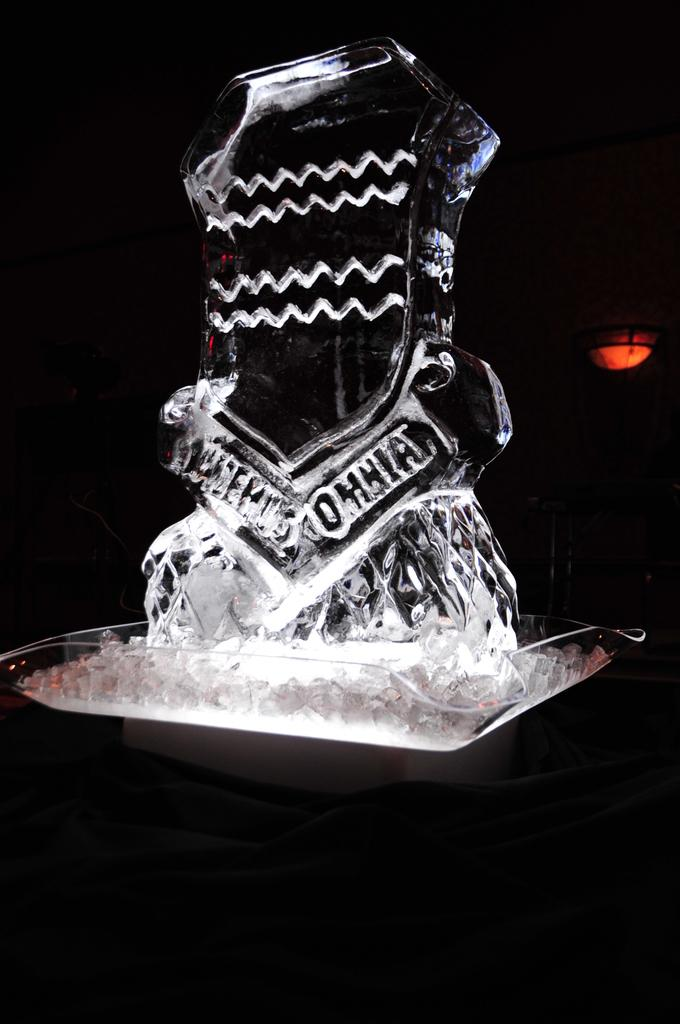What object is present in the image? There is a glass in the image. What color is the background of the image? The background of the image is black. What type of trade is being conducted in the image? There is no trade being conducted in the image; it only features a glass and a black background. How many times is the glass twisted in the image? The glass is not twisted in the image; it is stationary. 